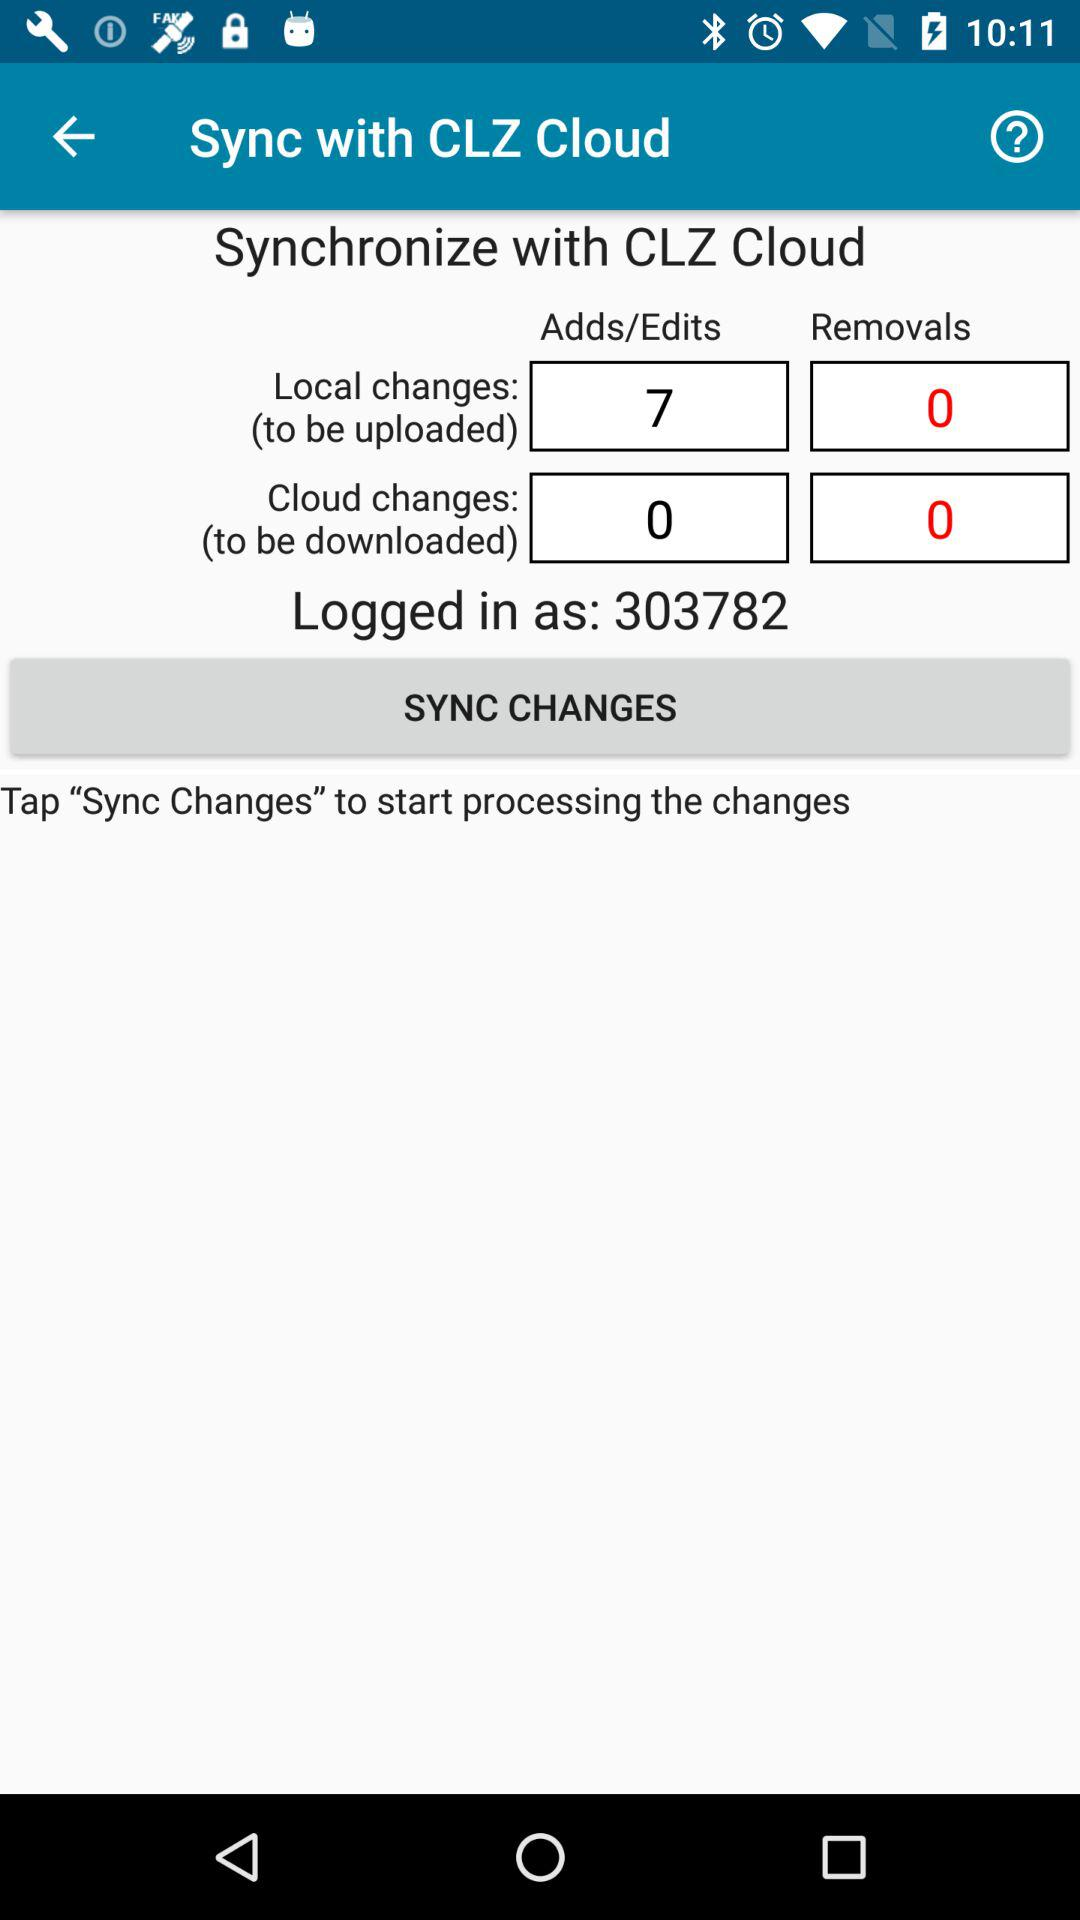How many changes are there in total?
Answer the question using a single word or phrase. 7 